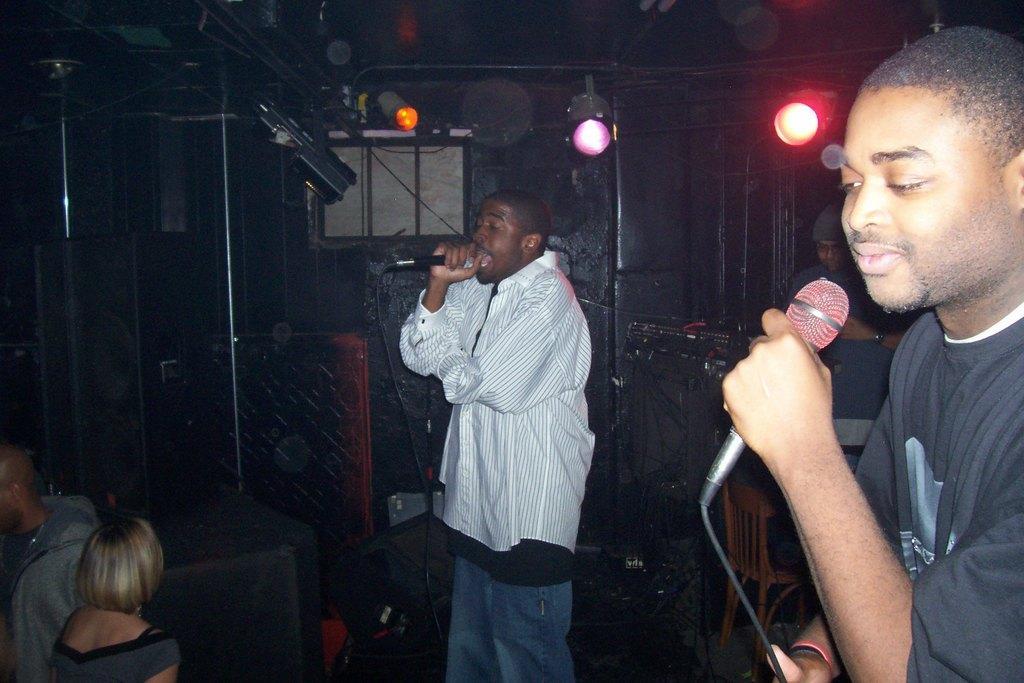In one or two sentences, can you explain what this image depicts? This image is clicked in a musical concert. There are 4 people, 5 people in this image. The one who is in the middle is singing. The one who is on the right side holding a mike. And there are two people in the bottom left corner. There are lights on the top. 